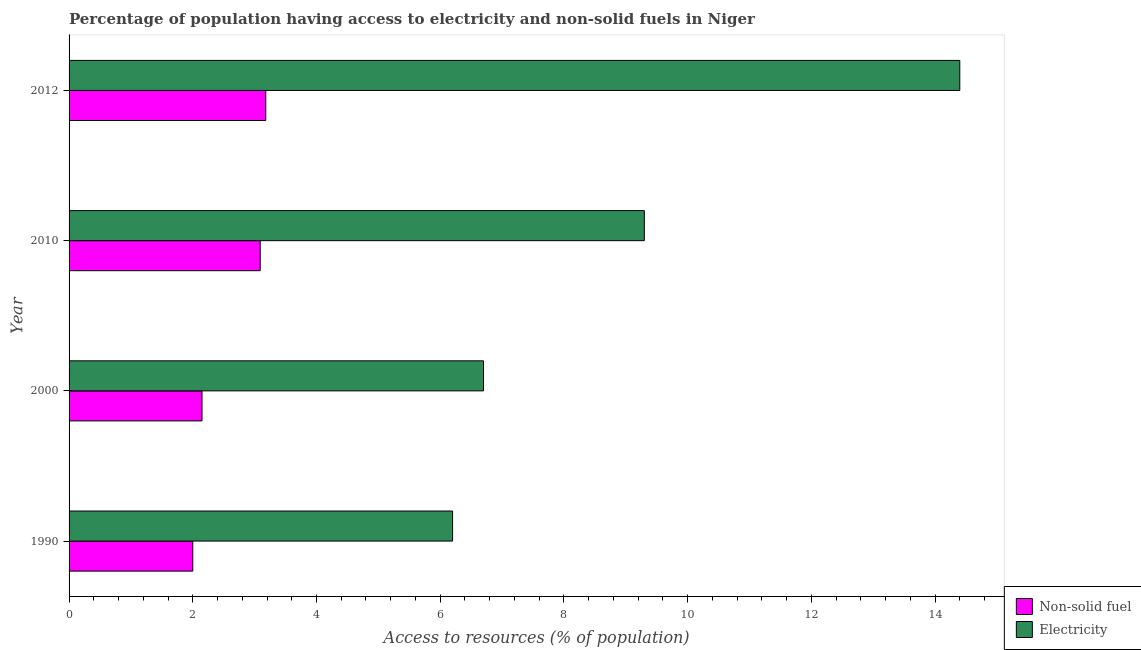How many different coloured bars are there?
Keep it short and to the point. 2. How many groups of bars are there?
Ensure brevity in your answer.  4. Are the number of bars per tick equal to the number of legend labels?
Offer a very short reply. Yes. What is the label of the 4th group of bars from the top?
Your response must be concise. 1990. What is the percentage of population having access to electricity in 2000?
Keep it short and to the point. 6.7. Across all years, what is the maximum percentage of population having access to non-solid fuel?
Provide a short and direct response. 3.18. Across all years, what is the minimum percentage of population having access to non-solid fuel?
Your response must be concise. 2. In which year was the percentage of population having access to non-solid fuel maximum?
Give a very brief answer. 2012. In which year was the percentage of population having access to electricity minimum?
Offer a very short reply. 1990. What is the total percentage of population having access to non-solid fuel in the graph?
Your answer should be very brief. 10.42. What is the difference between the percentage of population having access to electricity in 2012 and the percentage of population having access to non-solid fuel in 1990?
Provide a succinct answer. 12.4. What is the average percentage of population having access to electricity per year?
Make the answer very short. 9.15. In how many years, is the percentage of population having access to non-solid fuel greater than 7.6 %?
Make the answer very short. 0. What is the ratio of the percentage of population having access to non-solid fuel in 1990 to that in 2012?
Give a very brief answer. 0.63. Is the percentage of population having access to non-solid fuel in 2000 less than that in 2012?
Provide a short and direct response. Yes. Is the difference between the percentage of population having access to non-solid fuel in 1990 and 2012 greater than the difference between the percentage of population having access to electricity in 1990 and 2012?
Make the answer very short. Yes. What is the difference between the highest and the second highest percentage of population having access to non-solid fuel?
Keep it short and to the point. 0.09. What is the difference between the highest and the lowest percentage of population having access to electricity?
Your response must be concise. 8.2. In how many years, is the percentage of population having access to electricity greater than the average percentage of population having access to electricity taken over all years?
Your response must be concise. 2. What does the 1st bar from the top in 1990 represents?
Keep it short and to the point. Electricity. What does the 2nd bar from the bottom in 1990 represents?
Your response must be concise. Electricity. Are the values on the major ticks of X-axis written in scientific E-notation?
Your answer should be compact. No. Does the graph contain grids?
Make the answer very short. No. How many legend labels are there?
Your response must be concise. 2. How are the legend labels stacked?
Ensure brevity in your answer.  Vertical. What is the title of the graph?
Make the answer very short. Percentage of population having access to electricity and non-solid fuels in Niger. Does "Research and Development" appear as one of the legend labels in the graph?
Ensure brevity in your answer.  No. What is the label or title of the X-axis?
Keep it short and to the point. Access to resources (% of population). What is the Access to resources (% of population) in Non-solid fuel in 1990?
Provide a succinct answer. 2. What is the Access to resources (% of population) in Electricity in 1990?
Offer a terse response. 6.2. What is the Access to resources (% of population) of Non-solid fuel in 2000?
Your response must be concise. 2.15. What is the Access to resources (% of population) in Electricity in 2000?
Make the answer very short. 6.7. What is the Access to resources (% of population) in Non-solid fuel in 2010?
Ensure brevity in your answer.  3.09. What is the Access to resources (% of population) in Electricity in 2010?
Offer a very short reply. 9.3. What is the Access to resources (% of population) of Non-solid fuel in 2012?
Your answer should be very brief. 3.18. What is the Access to resources (% of population) in Electricity in 2012?
Make the answer very short. 14.4. Across all years, what is the maximum Access to resources (% of population) of Non-solid fuel?
Provide a short and direct response. 3.18. Across all years, what is the maximum Access to resources (% of population) in Electricity?
Ensure brevity in your answer.  14.4. Across all years, what is the minimum Access to resources (% of population) in Non-solid fuel?
Ensure brevity in your answer.  2. What is the total Access to resources (% of population) in Non-solid fuel in the graph?
Give a very brief answer. 10.42. What is the total Access to resources (% of population) of Electricity in the graph?
Your answer should be compact. 36.6. What is the difference between the Access to resources (% of population) of Non-solid fuel in 1990 and that in 2000?
Make the answer very short. -0.15. What is the difference between the Access to resources (% of population) of Electricity in 1990 and that in 2000?
Your response must be concise. -0.5. What is the difference between the Access to resources (% of population) in Non-solid fuel in 1990 and that in 2010?
Make the answer very short. -1.09. What is the difference between the Access to resources (% of population) of Electricity in 1990 and that in 2010?
Offer a terse response. -3.1. What is the difference between the Access to resources (% of population) in Non-solid fuel in 1990 and that in 2012?
Provide a short and direct response. -1.18. What is the difference between the Access to resources (% of population) of Non-solid fuel in 2000 and that in 2010?
Your answer should be very brief. -0.94. What is the difference between the Access to resources (% of population) of Electricity in 2000 and that in 2010?
Make the answer very short. -2.6. What is the difference between the Access to resources (% of population) of Non-solid fuel in 2000 and that in 2012?
Keep it short and to the point. -1.03. What is the difference between the Access to resources (% of population) of Non-solid fuel in 2010 and that in 2012?
Provide a short and direct response. -0.09. What is the difference between the Access to resources (% of population) of Non-solid fuel in 1990 and the Access to resources (% of population) of Electricity in 2010?
Provide a short and direct response. -7.3. What is the difference between the Access to resources (% of population) of Non-solid fuel in 2000 and the Access to resources (% of population) of Electricity in 2010?
Make the answer very short. -7.15. What is the difference between the Access to resources (% of population) of Non-solid fuel in 2000 and the Access to resources (% of population) of Electricity in 2012?
Ensure brevity in your answer.  -12.25. What is the difference between the Access to resources (% of population) of Non-solid fuel in 2010 and the Access to resources (% of population) of Electricity in 2012?
Offer a terse response. -11.31. What is the average Access to resources (% of population) of Non-solid fuel per year?
Give a very brief answer. 2.6. What is the average Access to resources (% of population) of Electricity per year?
Offer a terse response. 9.15. In the year 2000, what is the difference between the Access to resources (% of population) of Non-solid fuel and Access to resources (% of population) of Electricity?
Provide a short and direct response. -4.55. In the year 2010, what is the difference between the Access to resources (% of population) of Non-solid fuel and Access to resources (% of population) of Electricity?
Keep it short and to the point. -6.21. In the year 2012, what is the difference between the Access to resources (% of population) of Non-solid fuel and Access to resources (% of population) of Electricity?
Offer a very short reply. -11.22. What is the ratio of the Access to resources (% of population) of Non-solid fuel in 1990 to that in 2000?
Your answer should be very brief. 0.93. What is the ratio of the Access to resources (% of population) in Electricity in 1990 to that in 2000?
Ensure brevity in your answer.  0.93. What is the ratio of the Access to resources (% of population) in Non-solid fuel in 1990 to that in 2010?
Offer a terse response. 0.65. What is the ratio of the Access to resources (% of population) in Electricity in 1990 to that in 2010?
Provide a succinct answer. 0.67. What is the ratio of the Access to resources (% of population) of Non-solid fuel in 1990 to that in 2012?
Your response must be concise. 0.63. What is the ratio of the Access to resources (% of population) of Electricity in 1990 to that in 2012?
Make the answer very short. 0.43. What is the ratio of the Access to resources (% of population) of Non-solid fuel in 2000 to that in 2010?
Provide a short and direct response. 0.7. What is the ratio of the Access to resources (% of population) of Electricity in 2000 to that in 2010?
Your answer should be compact. 0.72. What is the ratio of the Access to resources (% of population) of Non-solid fuel in 2000 to that in 2012?
Offer a terse response. 0.68. What is the ratio of the Access to resources (% of population) in Electricity in 2000 to that in 2012?
Your response must be concise. 0.47. What is the ratio of the Access to resources (% of population) in Non-solid fuel in 2010 to that in 2012?
Offer a terse response. 0.97. What is the ratio of the Access to resources (% of population) in Electricity in 2010 to that in 2012?
Offer a terse response. 0.65. What is the difference between the highest and the second highest Access to resources (% of population) in Non-solid fuel?
Give a very brief answer. 0.09. What is the difference between the highest and the second highest Access to resources (% of population) of Electricity?
Provide a short and direct response. 5.1. What is the difference between the highest and the lowest Access to resources (% of population) in Non-solid fuel?
Provide a short and direct response. 1.18. 